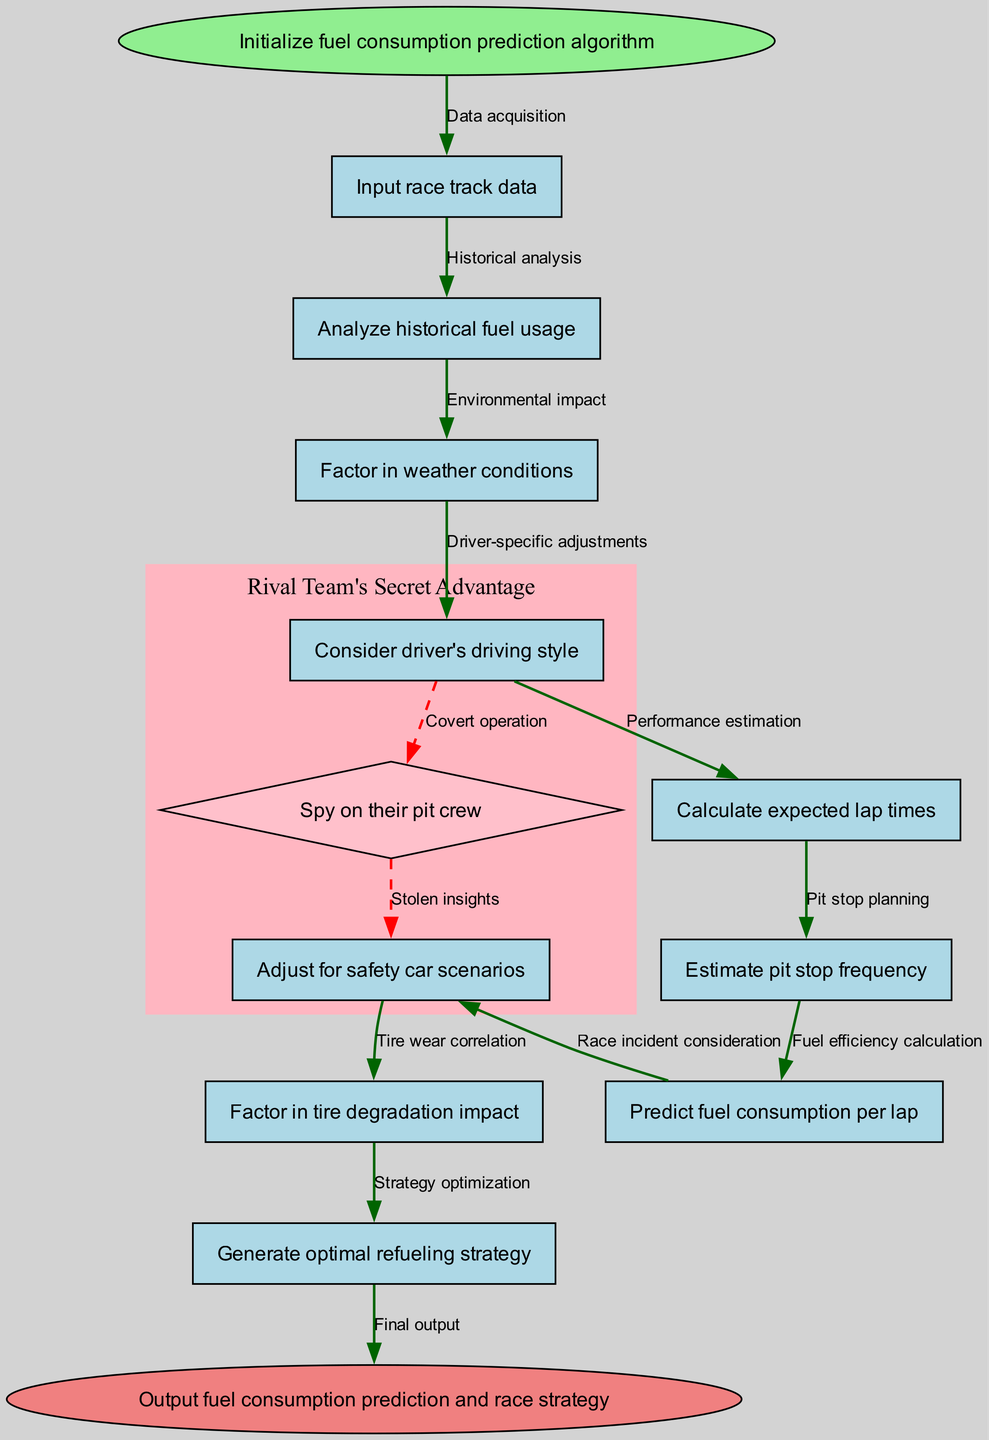What's the first step in the algorithm? The diagram starts with the node labeled "Initialize fuel consumption prediction algorithm," which indicates the beginning of the process.
Answer: Initialize fuel consumption prediction algorithm How many nodes are present in the diagram? By counting each process node listed in the nodes section, along with the start and end nodes, there are a total of 12 nodes.
Answer: 12 What does the node analyzing historical fuel usage lead to? The node "Analyze historical fuel usage" leads to the next node "Factor in weather conditions," indicating a sequential flow from one process to another.
Answer: Factor in weather conditions What is the last process before the final output? The last process node before the output node is "Generate optimal refueling strategy," which indicates the final step taken in the algorithm prior to the output.
Answer: Generate optimal refueling strategy Which step factors in tire degradation? The step that factors in tire degradation is labeled "Factor in tire degradation impact," connecting the analysis of tire wear to the overall fuel prediction algorithm.
Answer: Factor in tire degradation impact How many edges connect the nodes in the diagram? Each node has an edge connecting it to the next, with 11 edges formed between the 12 nodes, connecting sequentially from start to end.
Answer: 11 What two conditions are adjusted for when predicting fuel consumption? The conditions are weather conditions and safety car scenarios, which are both accounted for in different nodes to enhance prediction accuracy.
Answer: Weather conditions and safety car scenarios What type of adjustments does the diagram consider for the driver? The diagram includes "Consider driver's driving style," which means the algorithm takes individual driver characteristics into account when predicting fuel consumption.
Answer: Driver's driving style What is indicated by the subgraph in the diagram? The subgraph represents a secret advantage of the rival team, indicating that covert operations might provide them with insights on the fuel strategy and pit crew activities.
Answer: Rival team's secret advantage 